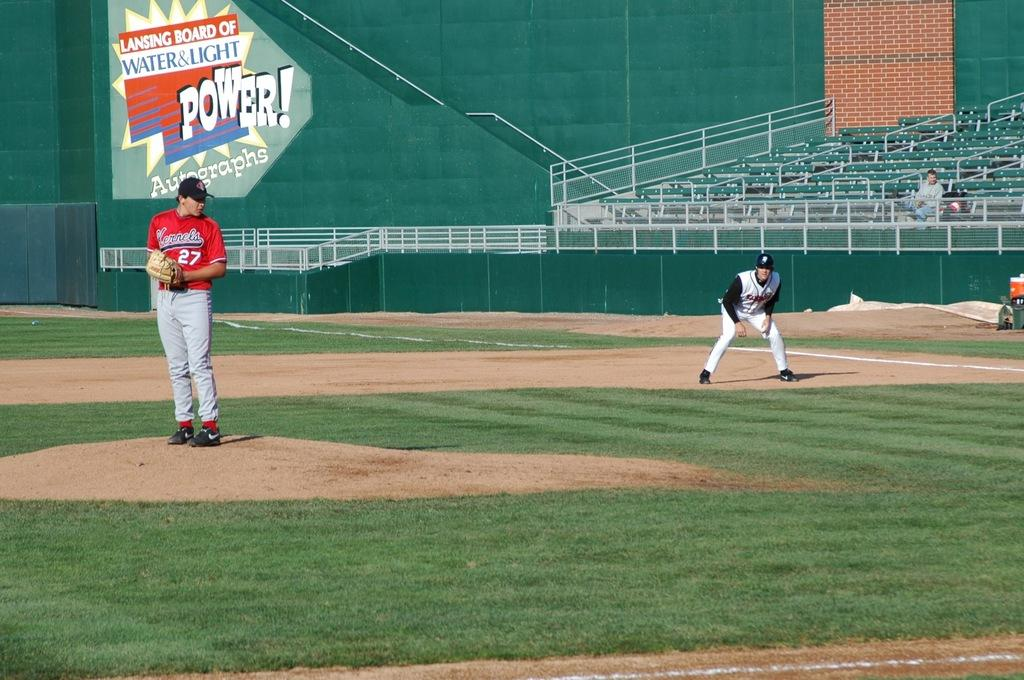<image>
Provide a brief description of the given image. A Kernels pitcher standing in front of a sign that says "Lansing Board of Water & Light" 